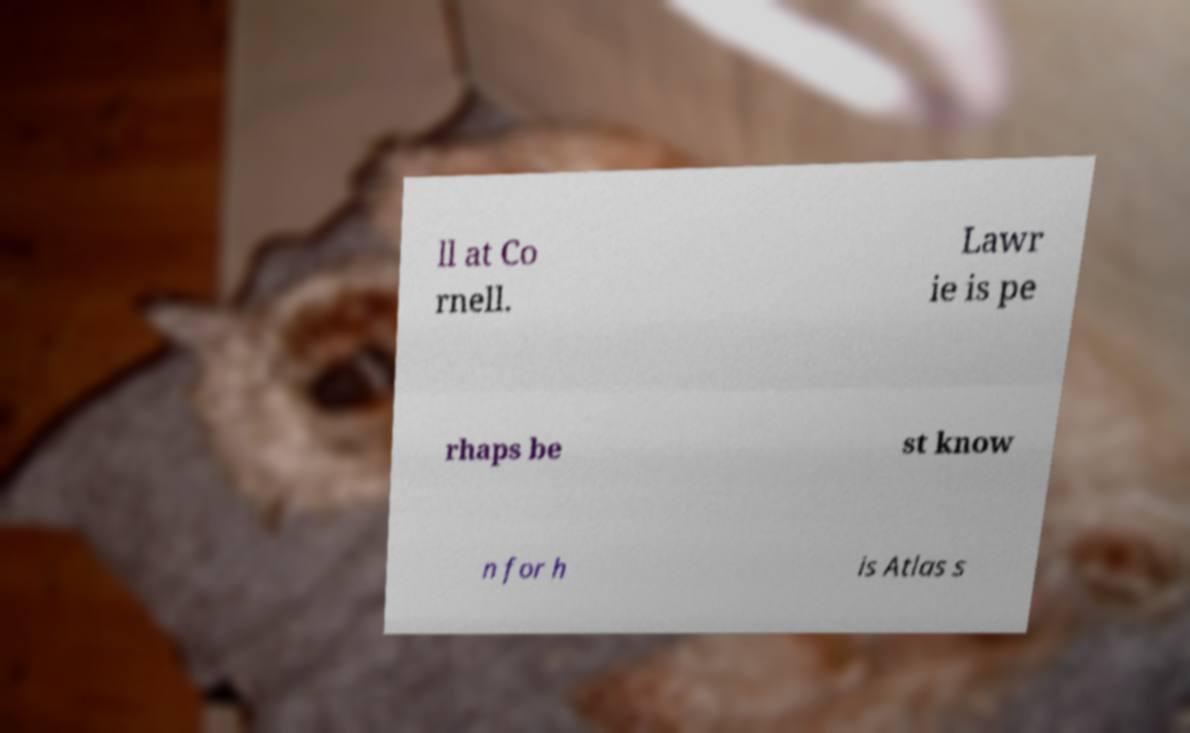Can you read and provide the text displayed in the image?This photo seems to have some interesting text. Can you extract and type it out for me? ll at Co rnell. Lawr ie is pe rhaps be st know n for h is Atlas s 